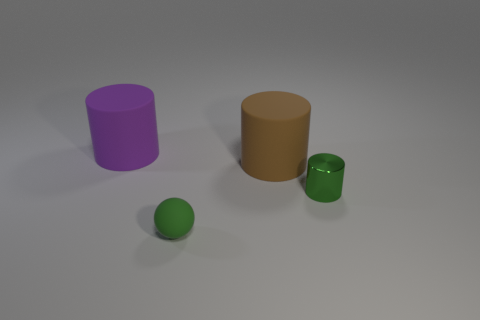Subtract all cyan cylinders. Subtract all blue spheres. How many cylinders are left? 3 Add 2 gray things. How many objects exist? 6 Subtract all balls. How many objects are left? 3 Subtract all rubber balls. Subtract all small gray objects. How many objects are left? 3 Add 1 green things. How many green things are left? 3 Add 3 big brown matte things. How many big brown matte things exist? 4 Subtract 0 purple blocks. How many objects are left? 4 